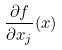<formula> <loc_0><loc_0><loc_500><loc_500>\frac { \partial f } { \partial x _ { j } } ( x )</formula> 